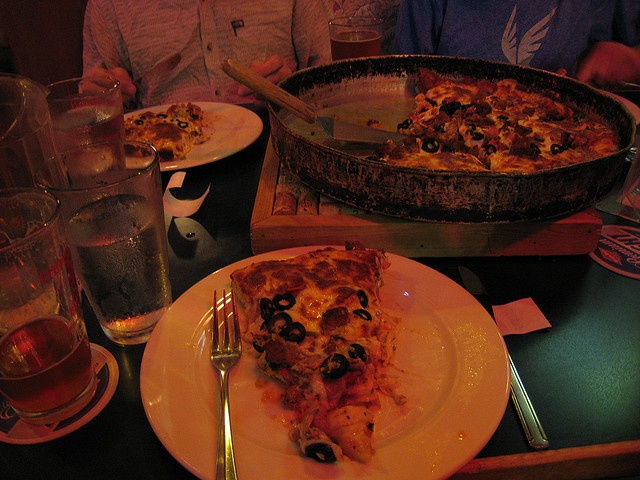Describe the objects in this image and their specific colors. I can see dining table in black, maroon, and brown tones, cup in black, maroon, and brown tones, pizza in black, maroon, and brown tones, people in black, maroon, and brown tones, and people in black, maroon, and brown tones in this image. 